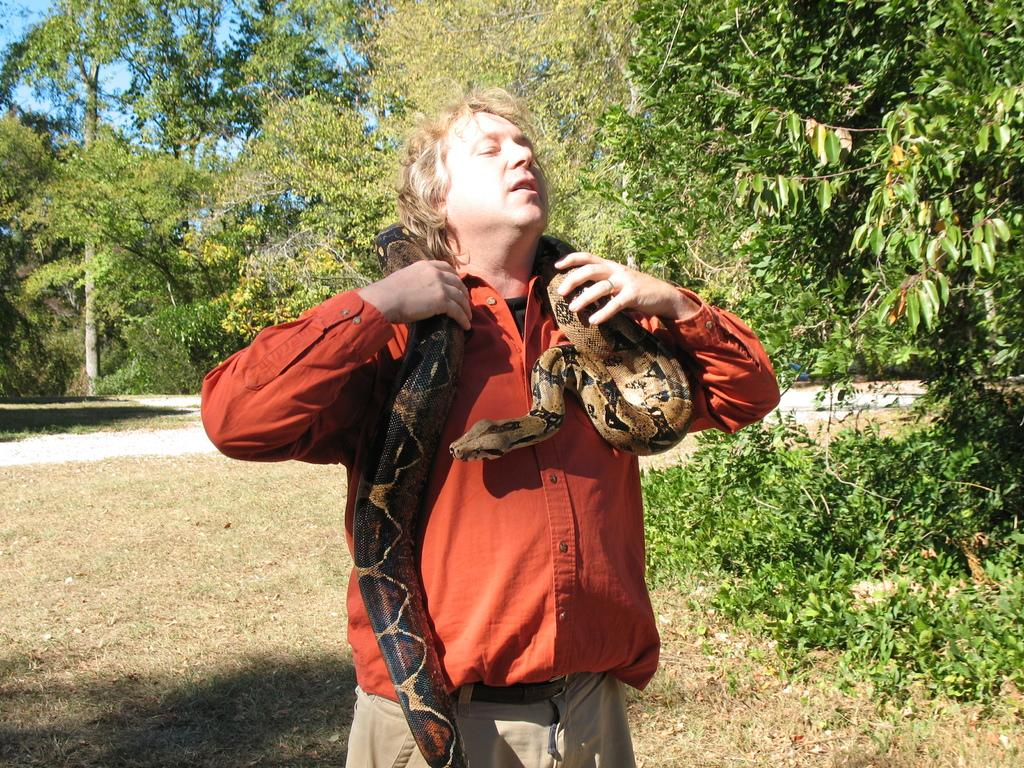What type of vegetation can be seen in the image? There are trees in the image. What type of man-made structure is present in the image? There is a road in the image. Can you describe the man in the image? The man has a snake around his neck. How many lizards can be seen in the image? There are no lizards present in the image. Is there a harbor visible in the image? There is no harbor present in the image. 